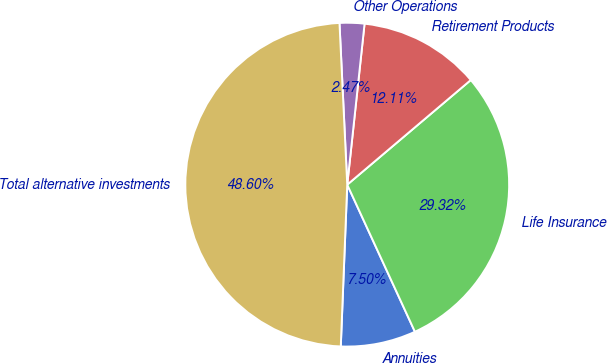Convert chart to OTSL. <chart><loc_0><loc_0><loc_500><loc_500><pie_chart><fcel>Annuities<fcel>Life Insurance<fcel>Retirement Products<fcel>Other Operations<fcel>Total alternative investments<nl><fcel>7.5%<fcel>29.32%<fcel>12.11%<fcel>2.47%<fcel>48.6%<nl></chart> 